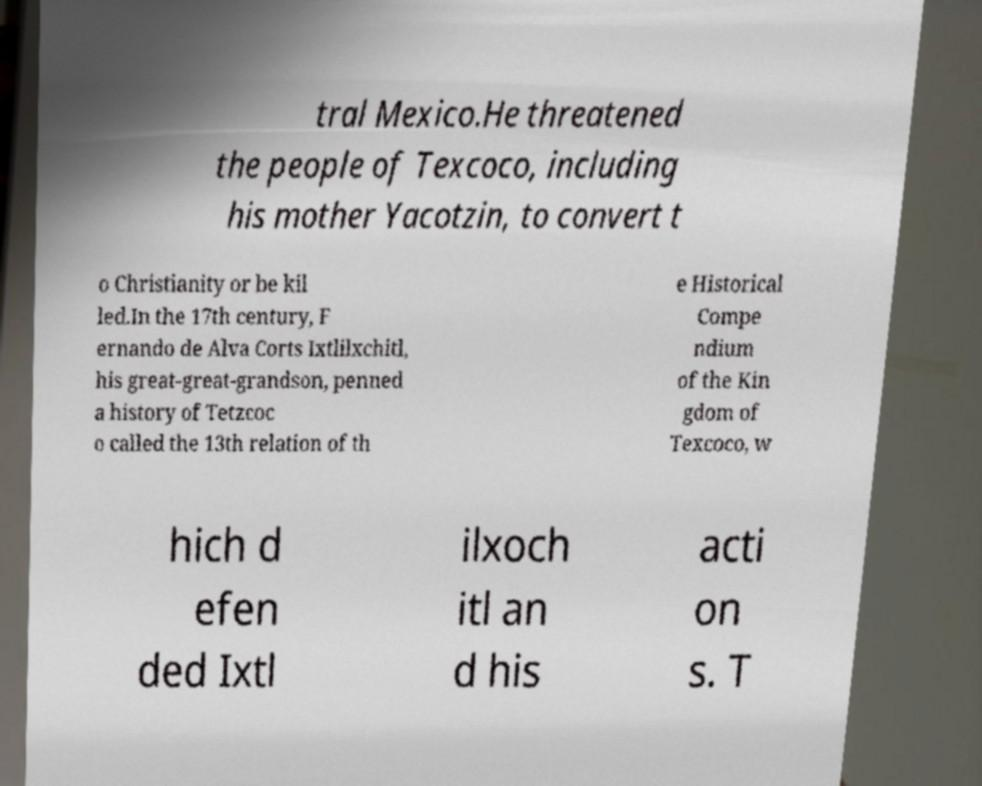What messages or text are displayed in this image? I need them in a readable, typed format. tral Mexico.He threatened the people of Texcoco, including his mother Yacotzin, to convert t o Christianity or be kil led.In the 17th century, F ernando de Alva Corts Ixtlilxchitl, his great-great-grandson, penned a history of Tetzcoc o called the 13th relation of th e Historical Compe ndium of the Kin gdom of Texcoco, w hich d efen ded Ixtl ilxoch itl an d his acti on s. T 